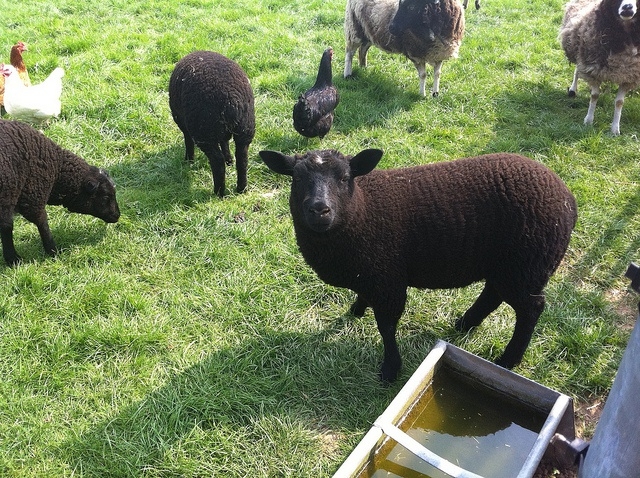Describe the objects in this image and their specific colors. I can see sheep in lightgreen, black, and gray tones, sheep in lightgreen, black, and gray tones, sheep in lightgreen, black, gray, and darkgray tones, sheep in lightgreen, gray, black, and darkgray tones, and sheep in lightgreen, gray, black, white, and darkgray tones in this image. 